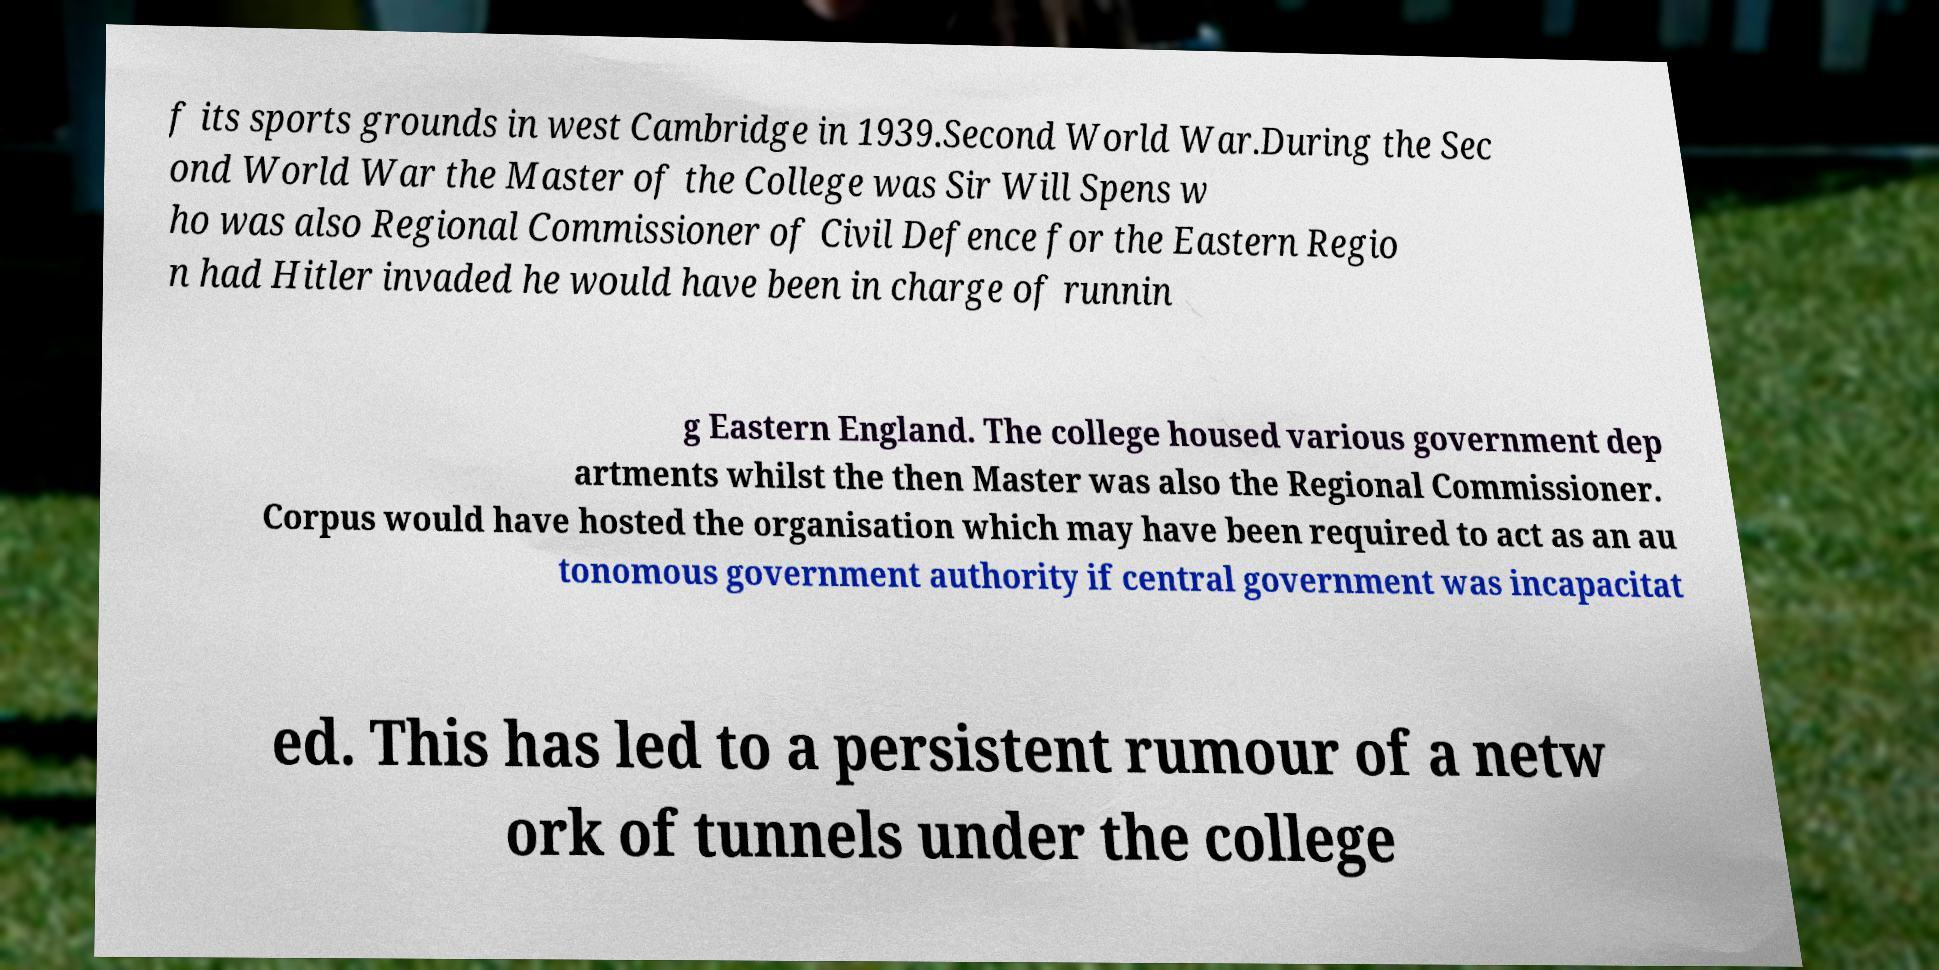Can you read and provide the text displayed in the image?This photo seems to have some interesting text. Can you extract and type it out for me? f its sports grounds in west Cambridge in 1939.Second World War.During the Sec ond World War the Master of the College was Sir Will Spens w ho was also Regional Commissioner of Civil Defence for the Eastern Regio n had Hitler invaded he would have been in charge of runnin g Eastern England. The college housed various government dep artments whilst the then Master was also the Regional Commissioner. Corpus would have hosted the organisation which may have been required to act as an au tonomous government authority if central government was incapacitat ed. This has led to a persistent rumour of a netw ork of tunnels under the college 